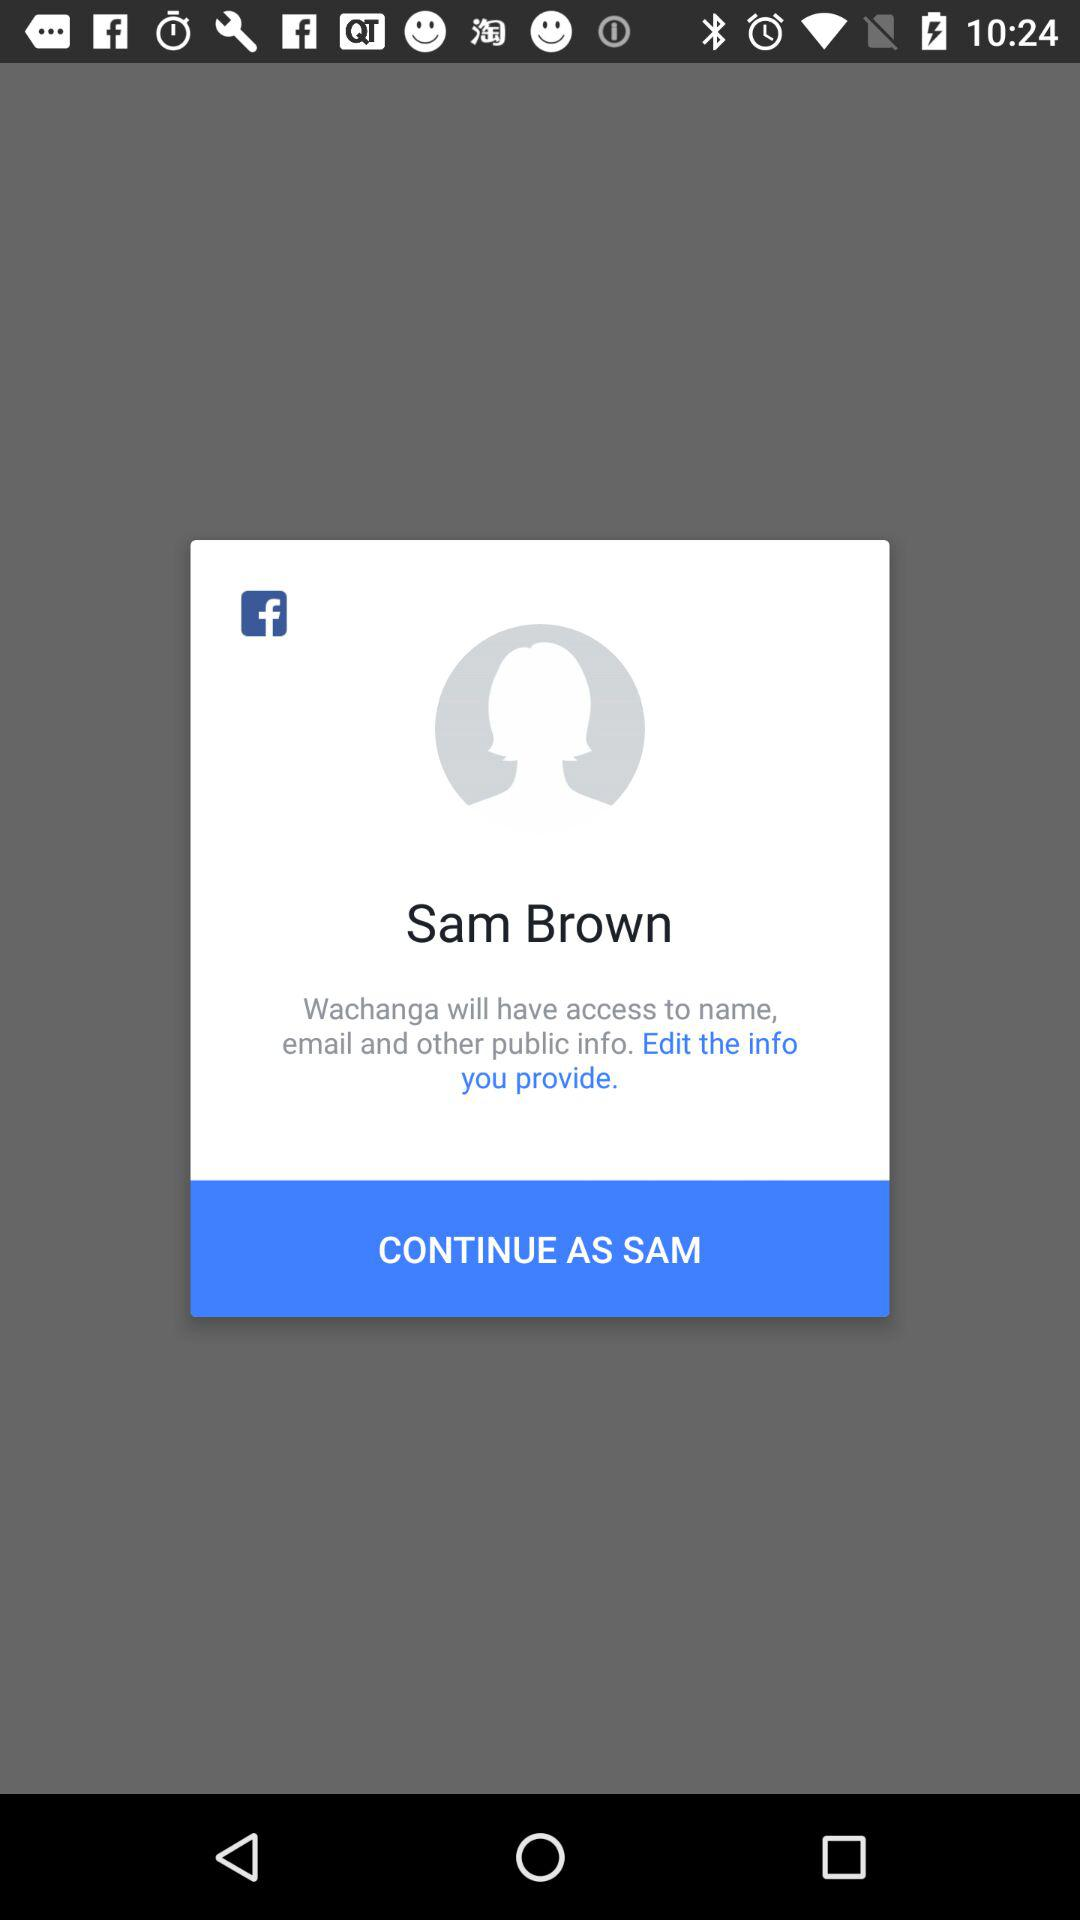What is the name of the user? The name of the user is "Sam Brown". 